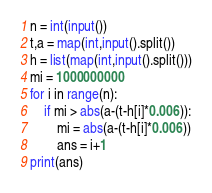Convert code to text. <code><loc_0><loc_0><loc_500><loc_500><_Python_>n = int(input())
t,a = map(int,input().split())
h = list(map(int,input().split()))
mi = 1000000000
for i in range(n):
    if mi > abs(a-(t-h[i]*0.006)):
        mi = abs(a-(t-h[i]*0.006))
        ans = i+1
print(ans)
</code> 